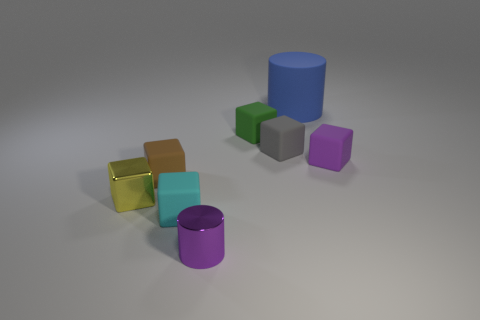Subtract all small rubber blocks. How many blocks are left? 1 Subtract all yellow blocks. How many blocks are left? 5 Subtract 4 cubes. How many cubes are left? 2 Add 7 small brown objects. How many small brown objects are left? 8 Add 2 yellow metal objects. How many yellow metal objects exist? 3 Add 2 cyan metal cylinders. How many objects exist? 10 Subtract 0 blue balls. How many objects are left? 8 Subtract all cylinders. How many objects are left? 6 Subtract all yellow blocks. Subtract all red cylinders. How many blocks are left? 5 Subtract all green balls. How many gray cylinders are left? 0 